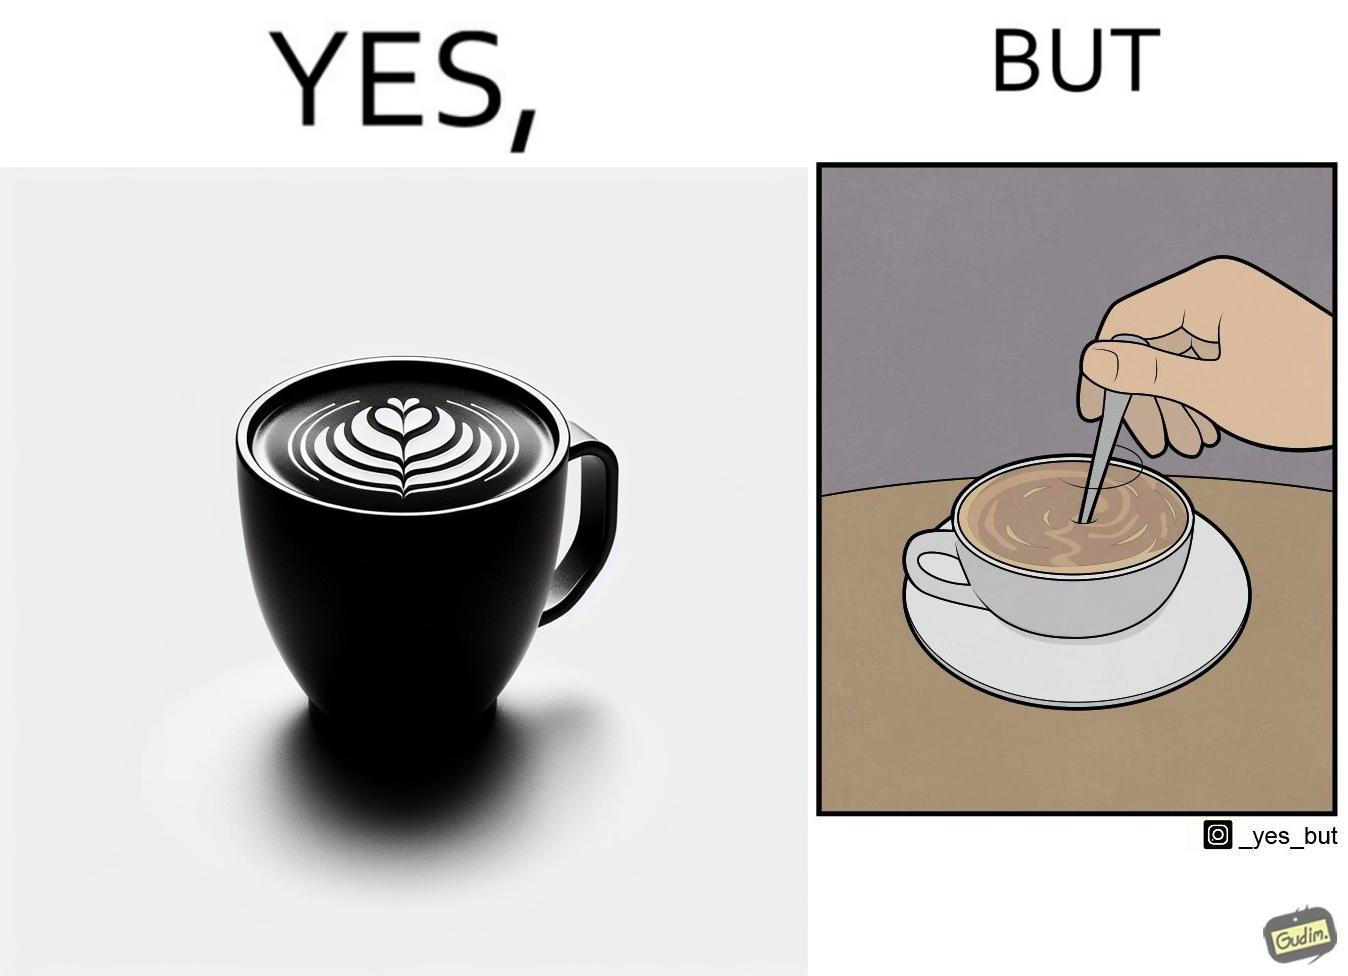Describe the content of this image. The image is ironic, because even when the coffee maker create latte art to make coffee look attractive but it is there just for a short time after that it is vanished 